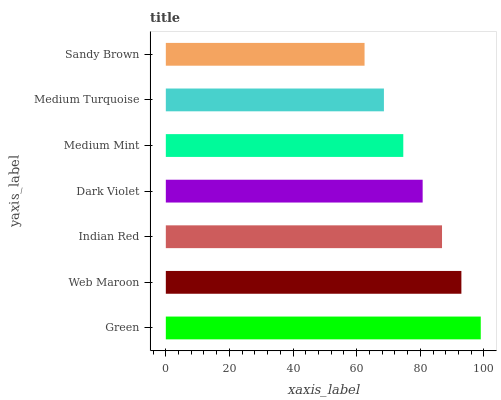Is Sandy Brown the minimum?
Answer yes or no. Yes. Is Green the maximum?
Answer yes or no. Yes. Is Web Maroon the minimum?
Answer yes or no. No. Is Web Maroon the maximum?
Answer yes or no. No. Is Green greater than Web Maroon?
Answer yes or no. Yes. Is Web Maroon less than Green?
Answer yes or no. Yes. Is Web Maroon greater than Green?
Answer yes or no. No. Is Green less than Web Maroon?
Answer yes or no. No. Is Dark Violet the high median?
Answer yes or no. Yes. Is Dark Violet the low median?
Answer yes or no. Yes. Is Medium Turquoise the high median?
Answer yes or no. No. Is Web Maroon the low median?
Answer yes or no. No. 